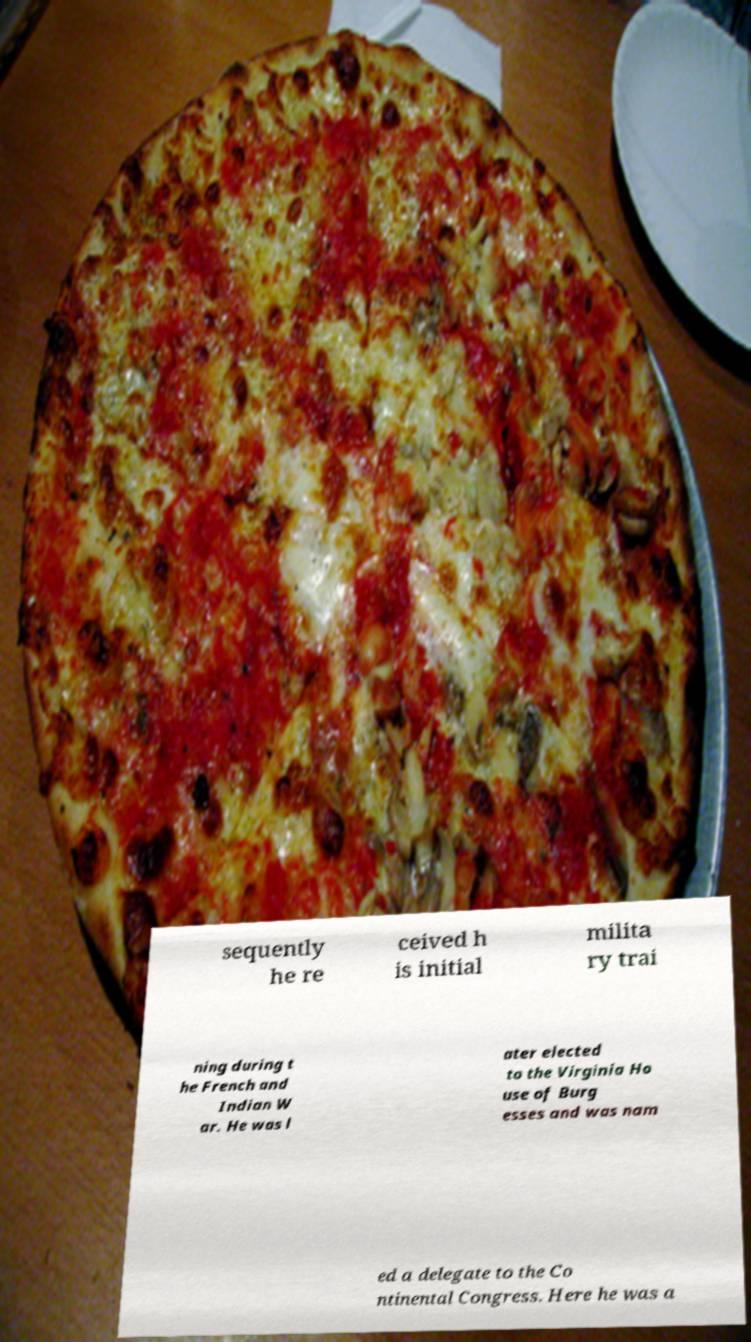Could you assist in decoding the text presented in this image and type it out clearly? sequently he re ceived h is initial milita ry trai ning during t he French and Indian W ar. He was l ater elected to the Virginia Ho use of Burg esses and was nam ed a delegate to the Co ntinental Congress. Here he was a 